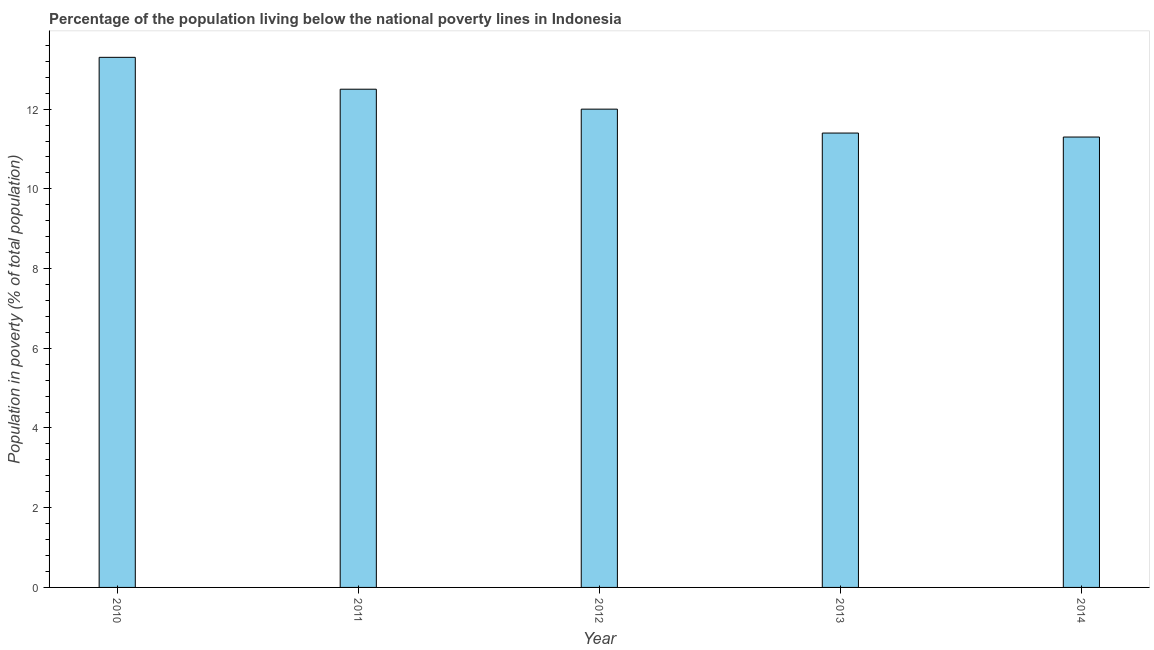Does the graph contain any zero values?
Your response must be concise. No. Does the graph contain grids?
Offer a terse response. No. What is the title of the graph?
Make the answer very short. Percentage of the population living below the national poverty lines in Indonesia. What is the label or title of the Y-axis?
Your answer should be very brief. Population in poverty (% of total population). In which year was the percentage of population living below poverty line maximum?
Your answer should be compact. 2010. What is the sum of the percentage of population living below poverty line?
Provide a short and direct response. 60.5. What is the difference between the percentage of population living below poverty line in 2013 and 2014?
Provide a succinct answer. 0.1. In how many years, is the percentage of population living below poverty line greater than 10.8 %?
Give a very brief answer. 5. Do a majority of the years between 2010 and 2012 (inclusive) have percentage of population living below poverty line greater than 1.6 %?
Keep it short and to the point. Yes. What is the ratio of the percentage of population living below poverty line in 2012 to that in 2014?
Ensure brevity in your answer.  1.06. Is the difference between the percentage of population living below poverty line in 2010 and 2011 greater than the difference between any two years?
Keep it short and to the point. No. How many bars are there?
Provide a short and direct response. 5. What is the Population in poverty (% of total population) in 2011?
Offer a terse response. 12.5. What is the Population in poverty (% of total population) of 2012?
Make the answer very short. 12. What is the Population in poverty (% of total population) in 2013?
Offer a very short reply. 11.4. What is the Population in poverty (% of total population) of 2014?
Keep it short and to the point. 11.3. What is the difference between the Population in poverty (% of total population) in 2010 and 2013?
Provide a short and direct response. 1.9. What is the difference between the Population in poverty (% of total population) in 2011 and 2012?
Give a very brief answer. 0.5. What is the difference between the Population in poverty (% of total population) in 2011 and 2013?
Provide a succinct answer. 1.1. What is the difference between the Population in poverty (% of total population) in 2012 and 2013?
Provide a succinct answer. 0.6. What is the ratio of the Population in poverty (% of total population) in 2010 to that in 2011?
Provide a succinct answer. 1.06. What is the ratio of the Population in poverty (% of total population) in 2010 to that in 2012?
Your response must be concise. 1.11. What is the ratio of the Population in poverty (% of total population) in 2010 to that in 2013?
Make the answer very short. 1.17. What is the ratio of the Population in poverty (% of total population) in 2010 to that in 2014?
Your answer should be compact. 1.18. What is the ratio of the Population in poverty (% of total population) in 2011 to that in 2012?
Offer a terse response. 1.04. What is the ratio of the Population in poverty (% of total population) in 2011 to that in 2013?
Ensure brevity in your answer.  1.1. What is the ratio of the Population in poverty (% of total population) in 2011 to that in 2014?
Ensure brevity in your answer.  1.11. What is the ratio of the Population in poverty (% of total population) in 2012 to that in 2013?
Keep it short and to the point. 1.05. What is the ratio of the Population in poverty (% of total population) in 2012 to that in 2014?
Your response must be concise. 1.06. 